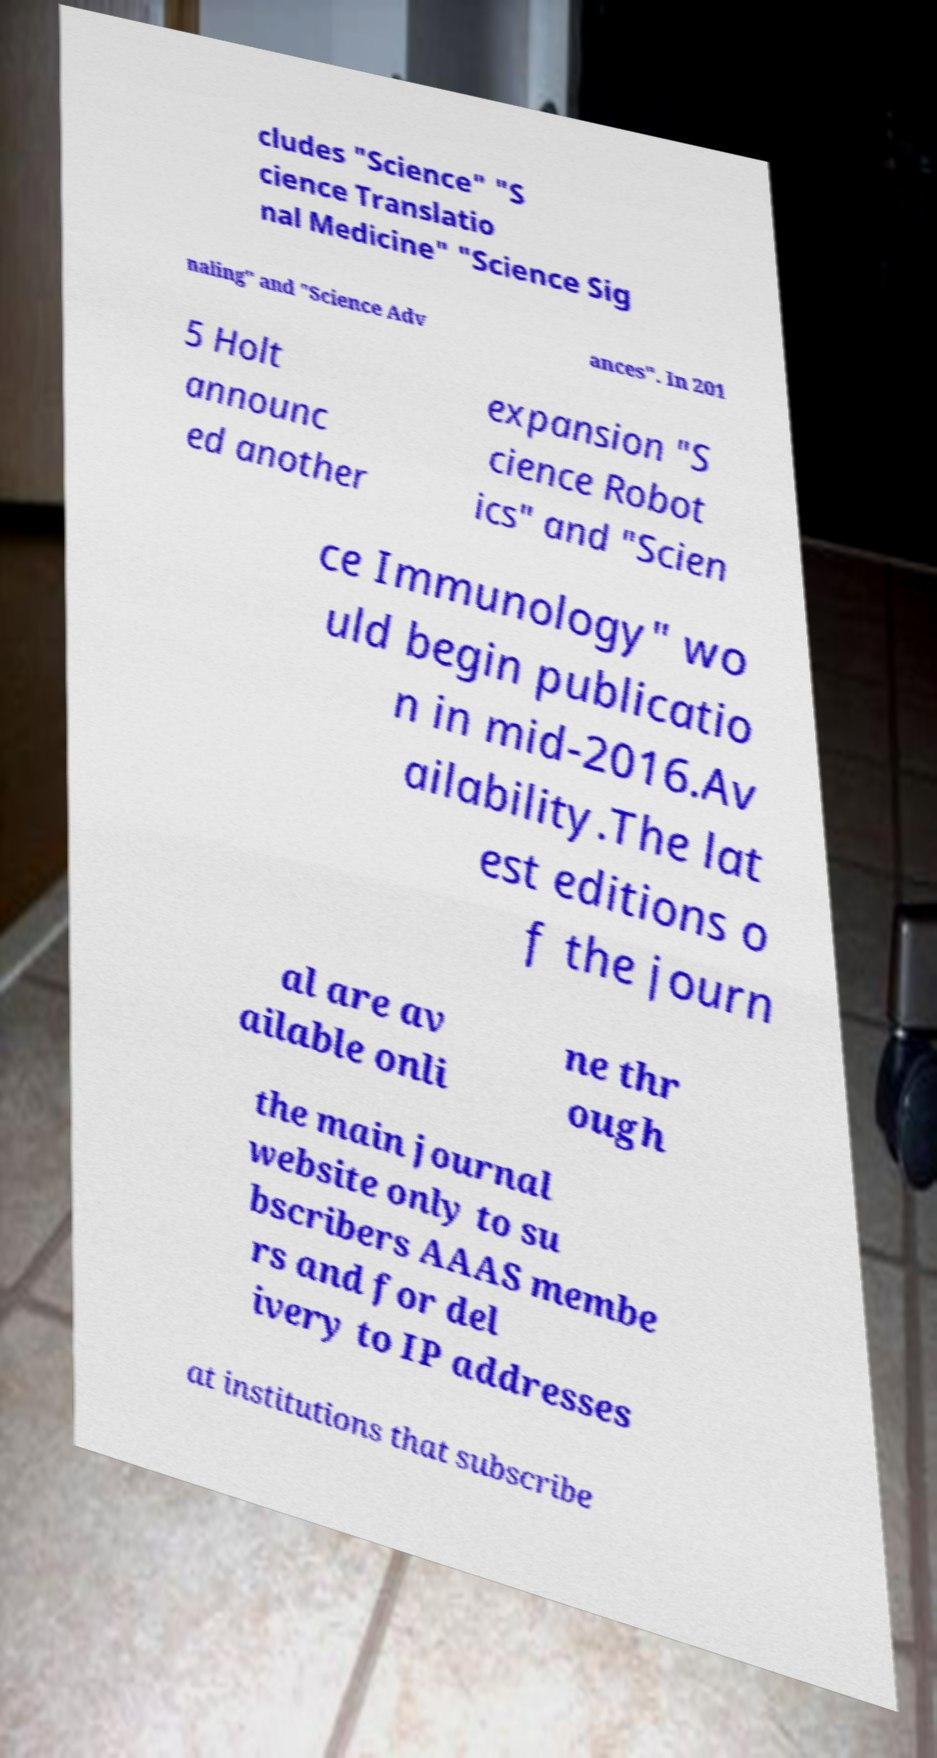There's text embedded in this image that I need extracted. Can you transcribe it verbatim? cludes "Science" "S cience Translatio nal Medicine" "Science Sig naling" and "Science Adv ances". In 201 5 Holt announc ed another expansion "S cience Robot ics" and "Scien ce Immunology" wo uld begin publicatio n in mid-2016.Av ailability.The lat est editions o f the journ al are av ailable onli ne thr ough the main journal website only to su bscribers AAAS membe rs and for del ivery to IP addresses at institutions that subscribe 